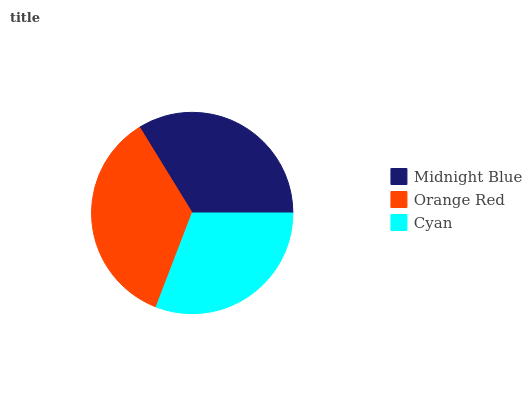Is Cyan the minimum?
Answer yes or no. Yes. Is Orange Red the maximum?
Answer yes or no. Yes. Is Orange Red the minimum?
Answer yes or no. No. Is Cyan the maximum?
Answer yes or no. No. Is Orange Red greater than Cyan?
Answer yes or no. Yes. Is Cyan less than Orange Red?
Answer yes or no. Yes. Is Cyan greater than Orange Red?
Answer yes or no. No. Is Orange Red less than Cyan?
Answer yes or no. No. Is Midnight Blue the high median?
Answer yes or no. Yes. Is Midnight Blue the low median?
Answer yes or no. Yes. Is Cyan the high median?
Answer yes or no. No. Is Orange Red the low median?
Answer yes or no. No. 